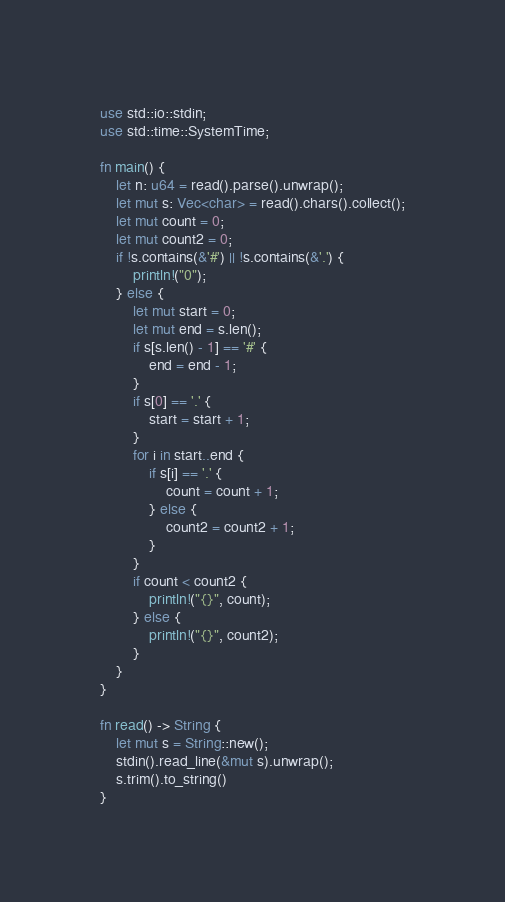Convert code to text. <code><loc_0><loc_0><loc_500><loc_500><_Rust_>use std::io::stdin;
use std::time::SystemTime;

fn main() {
    let n: u64 = read().parse().unwrap();
    let mut s: Vec<char> = read().chars().collect();
    let mut count = 0;
    let mut count2 = 0;
    if !s.contains(&'#') || !s.contains(&'.') {
        println!("0");
    } else {
        let mut start = 0;
        let mut end = s.len();
        if s[s.len() - 1] == '#' {
            end = end - 1;
        }
        if s[0] == '.' {
            start = start + 1;
        }
        for i in start..end {
            if s[i] == '.' {
                count = count + 1;
            } else {
                count2 = count2 + 1;
            }
        }
        if count < count2 {
            println!("{}", count);
        } else {
            println!("{}", count2);
        }
    }
}

fn read() -> String {
    let mut s = String::new();
    stdin().read_line(&mut s).unwrap();
    s.trim().to_string()
}
</code> 